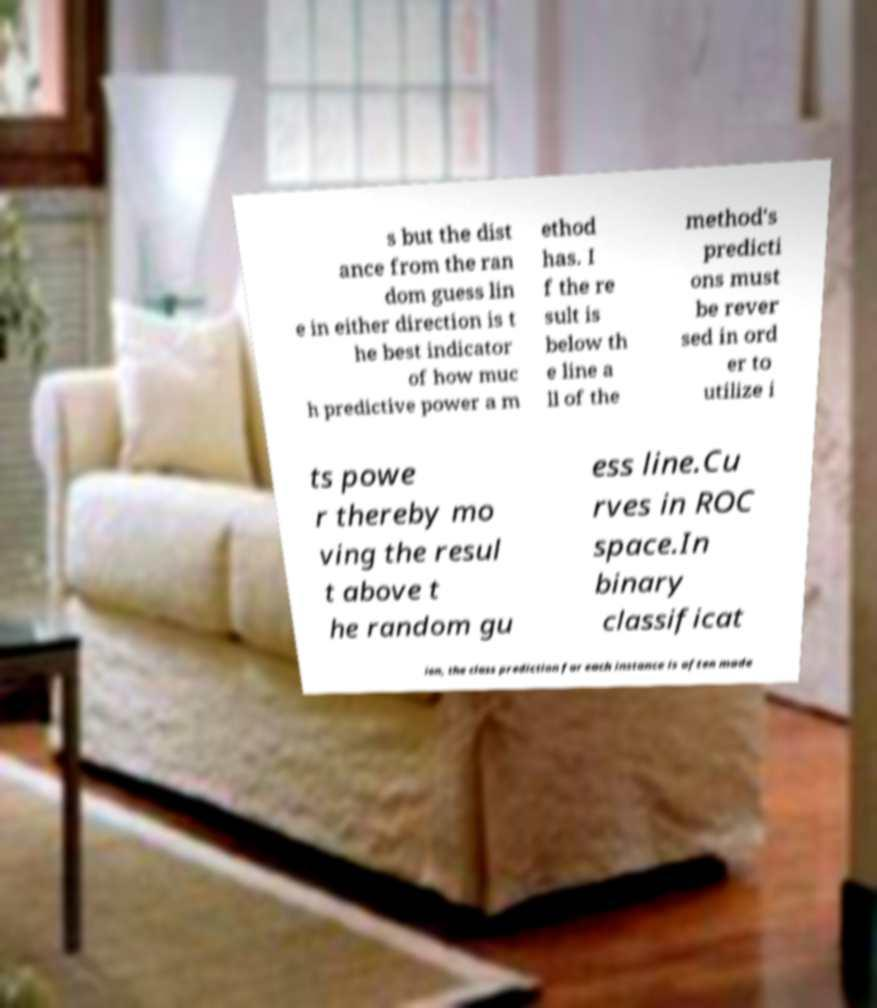Please read and relay the text visible in this image. What does it say? s but the dist ance from the ran dom guess lin e in either direction is t he best indicator of how muc h predictive power a m ethod has. I f the re sult is below th e line a ll of the method's predicti ons must be rever sed in ord er to utilize i ts powe r thereby mo ving the resul t above t he random gu ess line.Cu rves in ROC space.In binary classificat ion, the class prediction for each instance is often made 